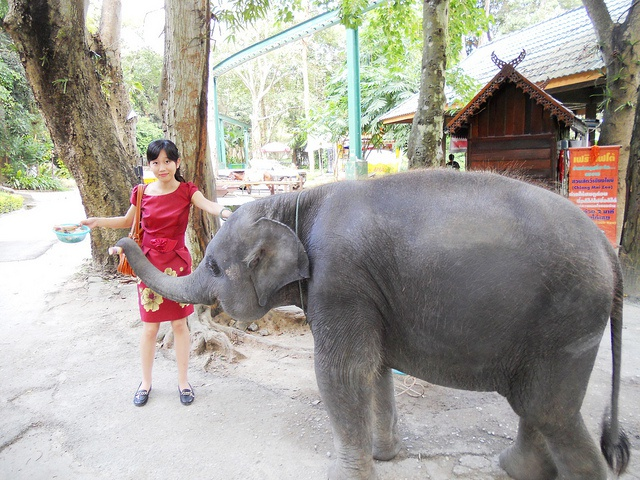Describe the objects in this image and their specific colors. I can see elephant in lightgreen, gray, darkgray, black, and lightgray tones, people in lightgreen, brown, tan, and lightgray tones, dining table in lightgreen, white, pink, darkgray, and tan tones, handbag in lightgreen, red, brown, and tan tones, and bench in lightgreen, white, tan, and darkgray tones in this image. 